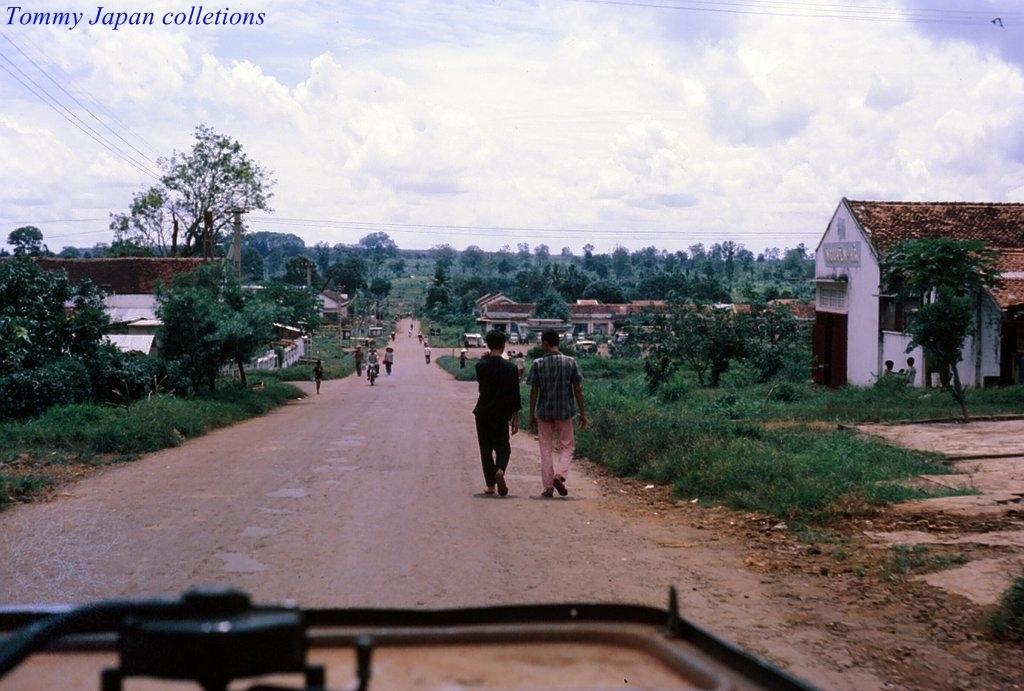Can you describe this image briefly? In the image there are many people moving on the road and on the either side of the road there are a lot of trees, plants and houses. In the background there is sky. 